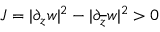Convert formula to latex. <formula><loc_0><loc_0><loc_500><loc_500>J = | \partial _ { z } w | ^ { 2 } - | \partial _ { \overline { z } } w | ^ { 2 } > 0</formula> 